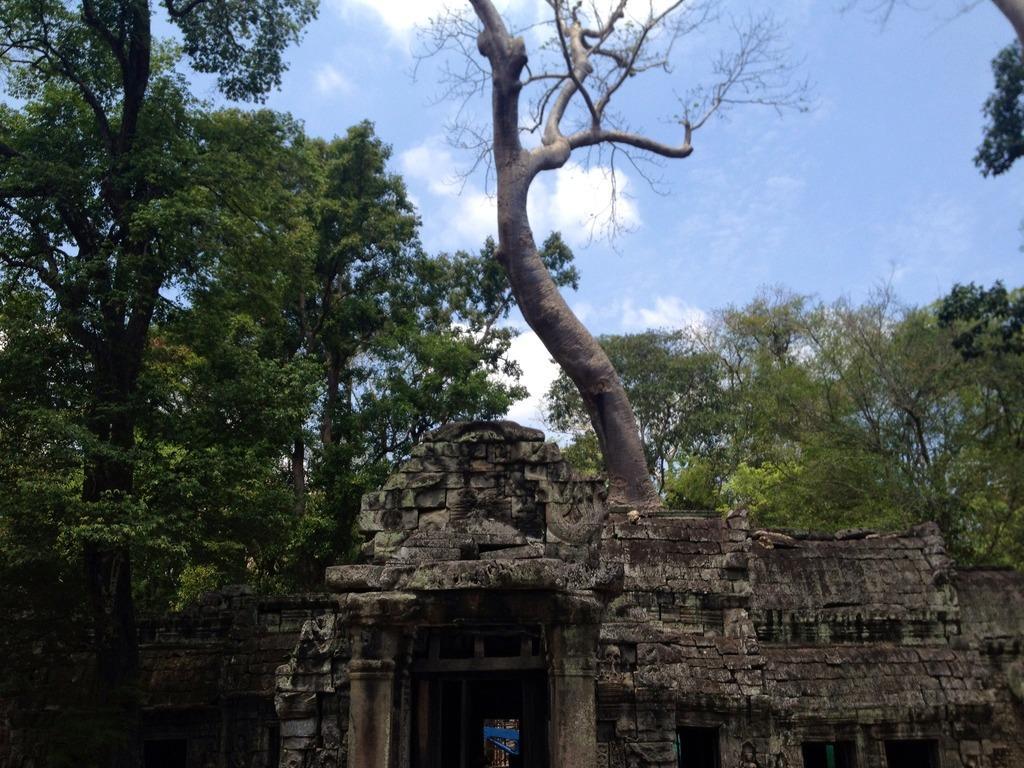Please provide a concise description of this image. This image looks like a fort. It is made up of rocks. In the front, we can see pillars. In the background, there are many trees. At the top, there is sky. 